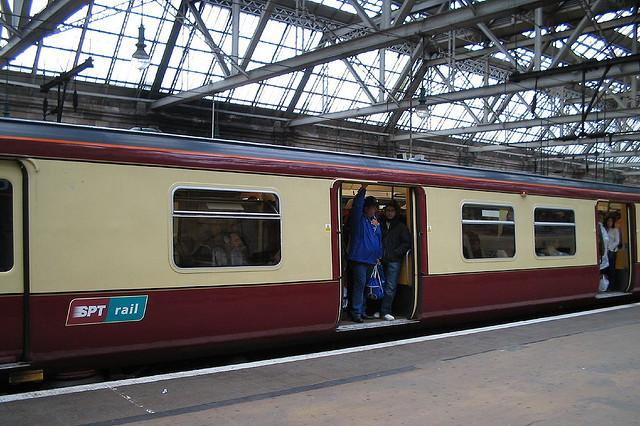What is the person wearing the blue coat about to do?

Choices:
A) board train
B) wave goodbye
C) serve lunch
D) get off get off 